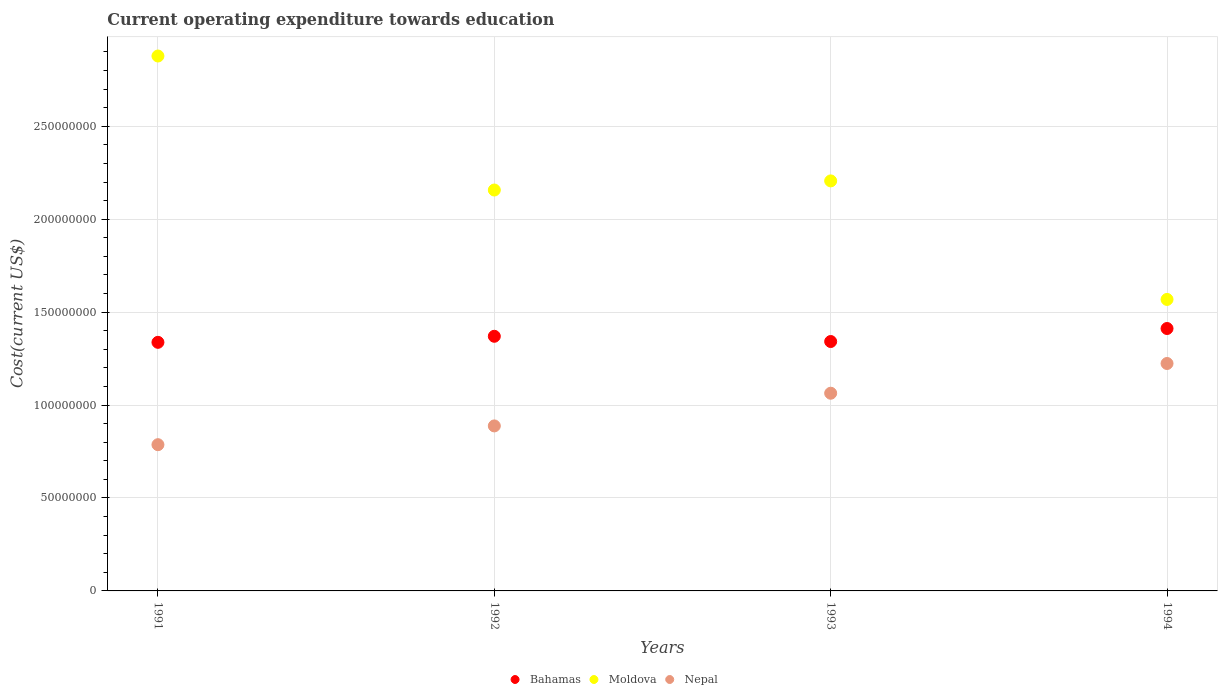What is the expenditure towards education in Bahamas in 1993?
Ensure brevity in your answer.  1.34e+08. Across all years, what is the maximum expenditure towards education in Nepal?
Offer a very short reply. 1.22e+08. Across all years, what is the minimum expenditure towards education in Moldova?
Your answer should be very brief. 1.57e+08. In which year was the expenditure towards education in Bahamas maximum?
Ensure brevity in your answer.  1994. What is the total expenditure towards education in Nepal in the graph?
Provide a succinct answer. 3.96e+08. What is the difference between the expenditure towards education in Moldova in 1991 and that in 1993?
Offer a terse response. 6.72e+07. What is the difference between the expenditure towards education in Bahamas in 1993 and the expenditure towards education in Nepal in 1994?
Offer a very short reply. 1.18e+07. What is the average expenditure towards education in Nepal per year?
Offer a very short reply. 9.90e+07. In the year 1992, what is the difference between the expenditure towards education in Moldova and expenditure towards education in Nepal?
Keep it short and to the point. 1.27e+08. What is the ratio of the expenditure towards education in Nepal in 1992 to that in 1994?
Offer a very short reply. 0.73. Is the expenditure towards education in Moldova in 1991 less than that in 1993?
Ensure brevity in your answer.  No. What is the difference between the highest and the second highest expenditure towards education in Nepal?
Your answer should be very brief. 1.60e+07. What is the difference between the highest and the lowest expenditure towards education in Bahamas?
Give a very brief answer. 7.43e+06. In how many years, is the expenditure towards education in Moldova greater than the average expenditure towards education in Moldova taken over all years?
Your answer should be compact. 2. Is the sum of the expenditure towards education in Moldova in 1991 and 1994 greater than the maximum expenditure towards education in Bahamas across all years?
Provide a short and direct response. Yes. Is it the case that in every year, the sum of the expenditure towards education in Nepal and expenditure towards education in Moldova  is greater than the expenditure towards education in Bahamas?
Provide a short and direct response. Yes. Does the expenditure towards education in Nepal monotonically increase over the years?
Offer a very short reply. Yes. Is the expenditure towards education in Nepal strictly greater than the expenditure towards education in Moldova over the years?
Provide a short and direct response. No. Is the expenditure towards education in Nepal strictly less than the expenditure towards education in Bahamas over the years?
Provide a short and direct response. Yes. How many dotlines are there?
Provide a short and direct response. 3. What is the difference between two consecutive major ticks on the Y-axis?
Offer a very short reply. 5.00e+07. Does the graph contain grids?
Your answer should be very brief. Yes. What is the title of the graph?
Ensure brevity in your answer.  Current operating expenditure towards education. Does "Europe(all income levels)" appear as one of the legend labels in the graph?
Your response must be concise. No. What is the label or title of the X-axis?
Provide a succinct answer. Years. What is the label or title of the Y-axis?
Ensure brevity in your answer.  Cost(current US$). What is the Cost(current US$) of Bahamas in 1991?
Your response must be concise. 1.34e+08. What is the Cost(current US$) in Moldova in 1991?
Your response must be concise. 2.88e+08. What is the Cost(current US$) in Nepal in 1991?
Ensure brevity in your answer.  7.87e+07. What is the Cost(current US$) in Bahamas in 1992?
Offer a very short reply. 1.37e+08. What is the Cost(current US$) of Moldova in 1992?
Your response must be concise. 2.16e+08. What is the Cost(current US$) in Nepal in 1992?
Ensure brevity in your answer.  8.88e+07. What is the Cost(current US$) of Bahamas in 1993?
Your answer should be compact. 1.34e+08. What is the Cost(current US$) of Moldova in 1993?
Ensure brevity in your answer.  2.21e+08. What is the Cost(current US$) of Nepal in 1993?
Your response must be concise. 1.06e+08. What is the Cost(current US$) in Bahamas in 1994?
Offer a terse response. 1.41e+08. What is the Cost(current US$) in Moldova in 1994?
Offer a terse response. 1.57e+08. What is the Cost(current US$) of Nepal in 1994?
Offer a terse response. 1.22e+08. Across all years, what is the maximum Cost(current US$) in Bahamas?
Make the answer very short. 1.41e+08. Across all years, what is the maximum Cost(current US$) in Moldova?
Ensure brevity in your answer.  2.88e+08. Across all years, what is the maximum Cost(current US$) of Nepal?
Ensure brevity in your answer.  1.22e+08. Across all years, what is the minimum Cost(current US$) in Bahamas?
Make the answer very short. 1.34e+08. Across all years, what is the minimum Cost(current US$) of Moldova?
Keep it short and to the point. 1.57e+08. Across all years, what is the minimum Cost(current US$) in Nepal?
Ensure brevity in your answer.  7.87e+07. What is the total Cost(current US$) in Bahamas in the graph?
Your answer should be compact. 5.46e+08. What is the total Cost(current US$) of Moldova in the graph?
Offer a very short reply. 8.81e+08. What is the total Cost(current US$) in Nepal in the graph?
Keep it short and to the point. 3.96e+08. What is the difference between the Cost(current US$) of Bahamas in 1991 and that in 1992?
Your answer should be compact. -3.25e+06. What is the difference between the Cost(current US$) in Moldova in 1991 and that in 1992?
Provide a short and direct response. 7.21e+07. What is the difference between the Cost(current US$) of Nepal in 1991 and that in 1992?
Provide a succinct answer. -1.01e+07. What is the difference between the Cost(current US$) in Bahamas in 1991 and that in 1993?
Ensure brevity in your answer.  -4.36e+05. What is the difference between the Cost(current US$) in Moldova in 1991 and that in 1993?
Keep it short and to the point. 6.72e+07. What is the difference between the Cost(current US$) in Nepal in 1991 and that in 1993?
Ensure brevity in your answer.  -2.77e+07. What is the difference between the Cost(current US$) in Bahamas in 1991 and that in 1994?
Your response must be concise. -7.43e+06. What is the difference between the Cost(current US$) of Moldova in 1991 and that in 1994?
Your answer should be very brief. 1.31e+08. What is the difference between the Cost(current US$) in Nepal in 1991 and that in 1994?
Ensure brevity in your answer.  -4.37e+07. What is the difference between the Cost(current US$) of Bahamas in 1992 and that in 1993?
Provide a short and direct response. 2.82e+06. What is the difference between the Cost(current US$) of Moldova in 1992 and that in 1993?
Your answer should be compact. -4.91e+06. What is the difference between the Cost(current US$) in Nepal in 1992 and that in 1993?
Make the answer very short. -1.76e+07. What is the difference between the Cost(current US$) in Bahamas in 1992 and that in 1994?
Offer a very short reply. -4.18e+06. What is the difference between the Cost(current US$) of Moldova in 1992 and that in 1994?
Provide a succinct answer. 5.89e+07. What is the difference between the Cost(current US$) in Nepal in 1992 and that in 1994?
Your answer should be very brief. -3.36e+07. What is the difference between the Cost(current US$) in Bahamas in 1993 and that in 1994?
Give a very brief answer. -7.00e+06. What is the difference between the Cost(current US$) of Moldova in 1993 and that in 1994?
Offer a very short reply. 6.38e+07. What is the difference between the Cost(current US$) of Nepal in 1993 and that in 1994?
Give a very brief answer. -1.60e+07. What is the difference between the Cost(current US$) of Bahamas in 1991 and the Cost(current US$) of Moldova in 1992?
Your answer should be compact. -8.19e+07. What is the difference between the Cost(current US$) in Bahamas in 1991 and the Cost(current US$) in Nepal in 1992?
Your answer should be compact. 4.50e+07. What is the difference between the Cost(current US$) of Moldova in 1991 and the Cost(current US$) of Nepal in 1992?
Give a very brief answer. 1.99e+08. What is the difference between the Cost(current US$) of Bahamas in 1991 and the Cost(current US$) of Moldova in 1993?
Keep it short and to the point. -8.68e+07. What is the difference between the Cost(current US$) of Bahamas in 1991 and the Cost(current US$) of Nepal in 1993?
Ensure brevity in your answer.  2.74e+07. What is the difference between the Cost(current US$) of Moldova in 1991 and the Cost(current US$) of Nepal in 1993?
Offer a terse response. 1.81e+08. What is the difference between the Cost(current US$) in Bahamas in 1991 and the Cost(current US$) in Moldova in 1994?
Provide a short and direct response. -2.31e+07. What is the difference between the Cost(current US$) in Bahamas in 1991 and the Cost(current US$) in Nepal in 1994?
Ensure brevity in your answer.  1.14e+07. What is the difference between the Cost(current US$) in Moldova in 1991 and the Cost(current US$) in Nepal in 1994?
Keep it short and to the point. 1.65e+08. What is the difference between the Cost(current US$) of Bahamas in 1992 and the Cost(current US$) of Moldova in 1993?
Offer a very short reply. -8.36e+07. What is the difference between the Cost(current US$) in Bahamas in 1992 and the Cost(current US$) in Nepal in 1993?
Your response must be concise. 3.06e+07. What is the difference between the Cost(current US$) in Moldova in 1992 and the Cost(current US$) in Nepal in 1993?
Ensure brevity in your answer.  1.09e+08. What is the difference between the Cost(current US$) of Bahamas in 1992 and the Cost(current US$) of Moldova in 1994?
Provide a short and direct response. -1.98e+07. What is the difference between the Cost(current US$) of Bahamas in 1992 and the Cost(current US$) of Nepal in 1994?
Give a very brief answer. 1.46e+07. What is the difference between the Cost(current US$) of Moldova in 1992 and the Cost(current US$) of Nepal in 1994?
Provide a succinct answer. 9.33e+07. What is the difference between the Cost(current US$) of Bahamas in 1993 and the Cost(current US$) of Moldova in 1994?
Your answer should be very brief. -2.26e+07. What is the difference between the Cost(current US$) in Bahamas in 1993 and the Cost(current US$) in Nepal in 1994?
Provide a succinct answer. 1.18e+07. What is the difference between the Cost(current US$) of Moldova in 1993 and the Cost(current US$) of Nepal in 1994?
Make the answer very short. 9.82e+07. What is the average Cost(current US$) in Bahamas per year?
Ensure brevity in your answer.  1.37e+08. What is the average Cost(current US$) of Moldova per year?
Offer a very short reply. 2.20e+08. What is the average Cost(current US$) of Nepal per year?
Ensure brevity in your answer.  9.90e+07. In the year 1991, what is the difference between the Cost(current US$) of Bahamas and Cost(current US$) of Moldova?
Your answer should be very brief. -1.54e+08. In the year 1991, what is the difference between the Cost(current US$) in Bahamas and Cost(current US$) in Nepal?
Your answer should be compact. 5.51e+07. In the year 1991, what is the difference between the Cost(current US$) of Moldova and Cost(current US$) of Nepal?
Offer a very short reply. 2.09e+08. In the year 1992, what is the difference between the Cost(current US$) in Bahamas and Cost(current US$) in Moldova?
Provide a short and direct response. -7.87e+07. In the year 1992, what is the difference between the Cost(current US$) in Bahamas and Cost(current US$) in Nepal?
Keep it short and to the point. 4.82e+07. In the year 1992, what is the difference between the Cost(current US$) in Moldova and Cost(current US$) in Nepal?
Give a very brief answer. 1.27e+08. In the year 1993, what is the difference between the Cost(current US$) of Bahamas and Cost(current US$) of Moldova?
Give a very brief answer. -8.64e+07. In the year 1993, what is the difference between the Cost(current US$) in Bahamas and Cost(current US$) in Nepal?
Give a very brief answer. 2.78e+07. In the year 1993, what is the difference between the Cost(current US$) in Moldova and Cost(current US$) in Nepal?
Your answer should be very brief. 1.14e+08. In the year 1994, what is the difference between the Cost(current US$) in Bahamas and Cost(current US$) in Moldova?
Your answer should be compact. -1.56e+07. In the year 1994, what is the difference between the Cost(current US$) in Bahamas and Cost(current US$) in Nepal?
Ensure brevity in your answer.  1.88e+07. In the year 1994, what is the difference between the Cost(current US$) in Moldova and Cost(current US$) in Nepal?
Ensure brevity in your answer.  3.45e+07. What is the ratio of the Cost(current US$) in Bahamas in 1991 to that in 1992?
Provide a succinct answer. 0.98. What is the ratio of the Cost(current US$) of Moldova in 1991 to that in 1992?
Your answer should be very brief. 1.33. What is the ratio of the Cost(current US$) in Nepal in 1991 to that in 1992?
Your response must be concise. 0.89. What is the ratio of the Cost(current US$) of Moldova in 1991 to that in 1993?
Ensure brevity in your answer.  1.3. What is the ratio of the Cost(current US$) in Nepal in 1991 to that in 1993?
Give a very brief answer. 0.74. What is the ratio of the Cost(current US$) of Bahamas in 1991 to that in 1994?
Make the answer very short. 0.95. What is the ratio of the Cost(current US$) in Moldova in 1991 to that in 1994?
Offer a terse response. 1.84. What is the ratio of the Cost(current US$) of Nepal in 1991 to that in 1994?
Your answer should be compact. 0.64. What is the ratio of the Cost(current US$) in Bahamas in 1992 to that in 1993?
Ensure brevity in your answer.  1.02. What is the ratio of the Cost(current US$) in Moldova in 1992 to that in 1993?
Make the answer very short. 0.98. What is the ratio of the Cost(current US$) in Nepal in 1992 to that in 1993?
Provide a succinct answer. 0.83. What is the ratio of the Cost(current US$) in Bahamas in 1992 to that in 1994?
Make the answer very short. 0.97. What is the ratio of the Cost(current US$) of Moldova in 1992 to that in 1994?
Give a very brief answer. 1.38. What is the ratio of the Cost(current US$) of Nepal in 1992 to that in 1994?
Make the answer very short. 0.73. What is the ratio of the Cost(current US$) of Bahamas in 1993 to that in 1994?
Offer a terse response. 0.95. What is the ratio of the Cost(current US$) in Moldova in 1993 to that in 1994?
Your answer should be very brief. 1.41. What is the ratio of the Cost(current US$) in Nepal in 1993 to that in 1994?
Ensure brevity in your answer.  0.87. What is the difference between the highest and the second highest Cost(current US$) in Bahamas?
Make the answer very short. 4.18e+06. What is the difference between the highest and the second highest Cost(current US$) in Moldova?
Give a very brief answer. 6.72e+07. What is the difference between the highest and the second highest Cost(current US$) in Nepal?
Your answer should be compact. 1.60e+07. What is the difference between the highest and the lowest Cost(current US$) in Bahamas?
Offer a very short reply. 7.43e+06. What is the difference between the highest and the lowest Cost(current US$) in Moldova?
Ensure brevity in your answer.  1.31e+08. What is the difference between the highest and the lowest Cost(current US$) in Nepal?
Give a very brief answer. 4.37e+07. 